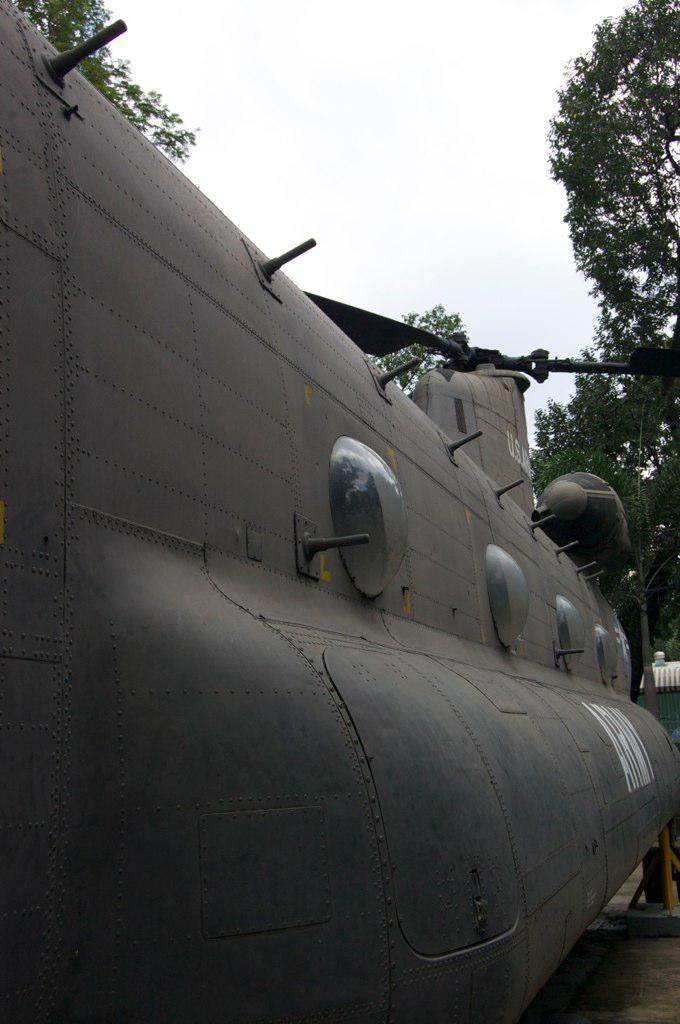What type of vehicle is on the left side of the image? There is a gray color aircraft on the left side of the image. What feature can be seen on the aircraft? The aircraft has glass windows and a fan on the top. What can be seen in the background of the image? There are trees in the background of the image. What is visible in the sky in the image? There are clouds in the sky. What type of plantation can be seen in the image? There is no plantation present in the image; it features an aircraft and a background with trees. Is there anyone reading a book in the image? There is no person or book visible in the image. 